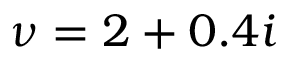Convert formula to latex. <formula><loc_0><loc_0><loc_500><loc_500>\nu = 2 + 0 . 4 i</formula> 